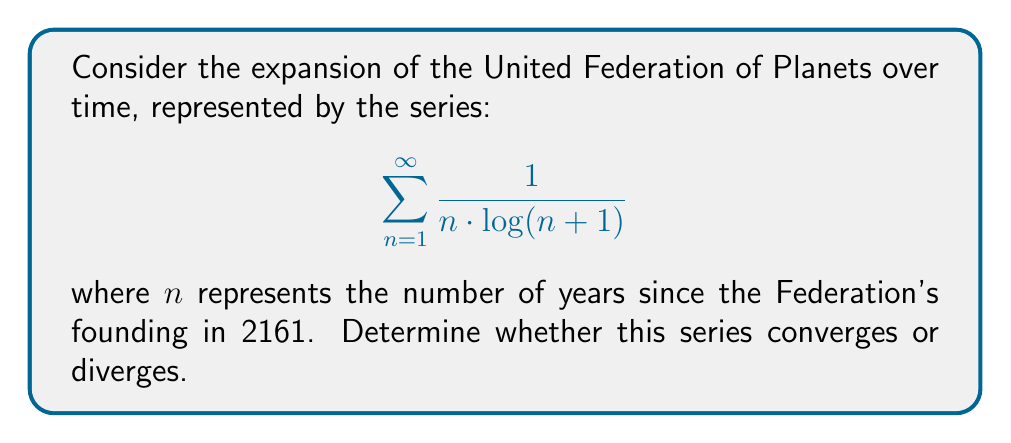What is the answer to this math problem? To determine the convergence of this series, we'll use the integral test, which is appropriate for a decreasing, positive function.

Step 1: Let $f(x) = \frac{1}{x \cdot \log(x+1)}$. This function is positive and decreasing for $x \geq 1$.

Step 2: Set up the improper integral:

$$\int_{1}^{\infty} \frac{1}{x \cdot \log(x+1)} dx$$

Step 3: Use the substitution $u = \log(x+1)$, $du = \frac{1}{x+1} dx$:

$$\int_{1}^{\infty} \frac{1}{x \cdot \log(x+1)} dx = \int_{\log 2}^{\infty} \frac{1}{u(e^u - 1)} du$$

Step 4: For large $u$, $e^u - 1 \approx e^u$, so we can compare our integral to:

$$\int_{\log 2}^{\infty} \frac{1}{ue^u} du$$

Step 5: This integral converges because:

$$\int_{\log 2}^{\infty} \frac{1}{ue^u} du < \int_{\log 2}^{\infty} \frac{1}{e^u} du = \left[-\frac{1}{e^u}\right]_{\log 2}^{\infty} = \frac{1}{2} < \infty$$

Step 6: Since the improper integral converges, by the integral test, the original series also converges.

This result aligns with the established Star Trek canon, suggesting a gradual and sustainable expansion of the Federation over time, rather than an explosive, divergent growth.
Answer: The series converges. 